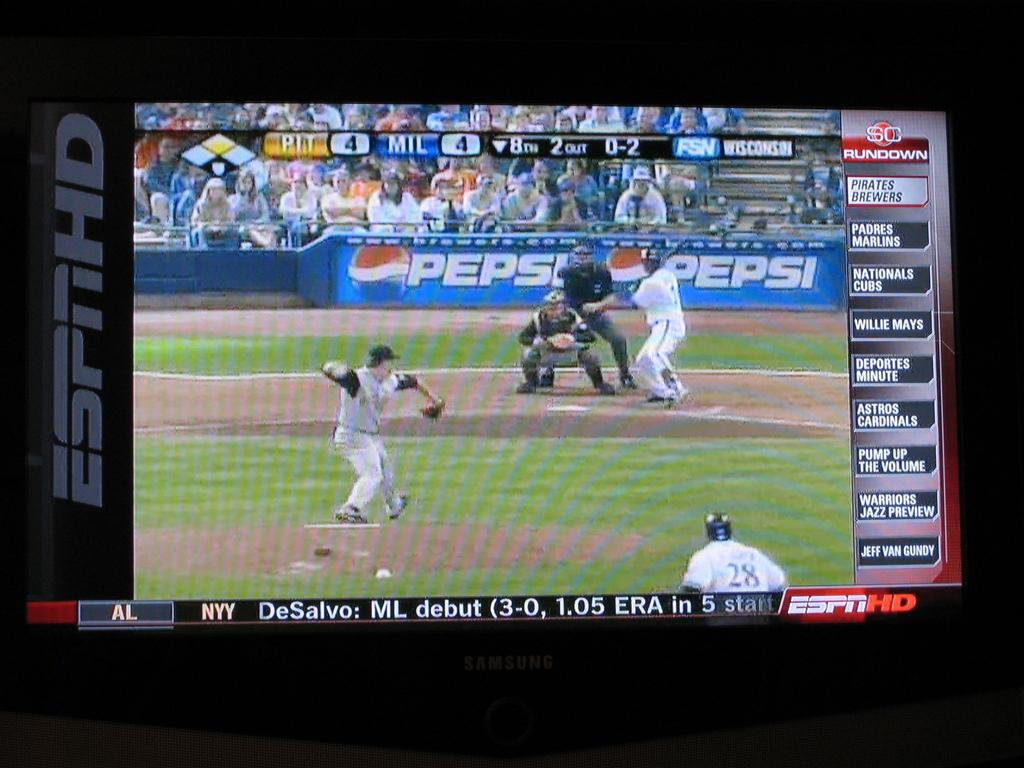<image>
Provide a brief description of the given image. a game of baseball with a Pepsi logo in the back 